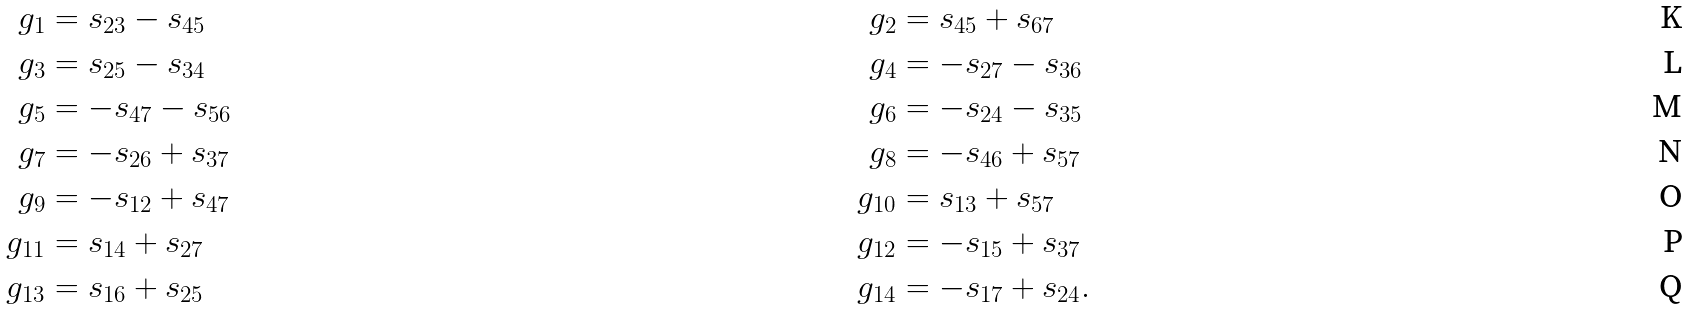<formula> <loc_0><loc_0><loc_500><loc_500>g _ { 1 } & = s _ { 2 3 } - s _ { 4 5 } & \quad g _ { 2 } & = s _ { 4 5 } + s _ { 6 7 } \\ g _ { 3 } & = s _ { 2 5 } - s _ { 3 4 } & \quad g _ { 4 } & = - s _ { 2 7 } - s _ { 3 6 } \\ g _ { 5 } & = - s _ { 4 7 } - s _ { 5 6 } & \quad g _ { 6 } & = - s _ { 2 4 } - s _ { 3 5 } \\ g _ { 7 } & = - s _ { 2 6 } + s _ { 3 7 } & \quad g _ { 8 } & = - s _ { 4 6 } + s _ { 5 7 } \\ g _ { 9 } & = - s _ { 1 2 } + s _ { 4 7 } & \quad g _ { 1 0 } & = s _ { 1 3 } + s _ { 5 7 } \\ g _ { 1 1 } & = s _ { 1 4 } + s _ { 2 7 } & \quad g _ { 1 2 } & = - s _ { 1 5 } + s _ { 3 7 } \\ g _ { 1 3 } & = s _ { 1 6 } + s _ { 2 5 } & \quad g _ { 1 4 } & = - s _ { 1 7 } + s _ { 2 4 } .</formula> 